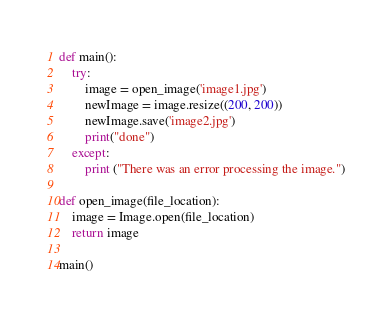<code> <loc_0><loc_0><loc_500><loc_500><_Python_>
def main():
    try:
        image = open_image('image1.jpg')
        newImage = image.resize((200, 200))
        newImage.save('image2.jpg')
        print("done")
    except:
        print ("There was an error processing the image.")

def open_image(file_location):
    image = Image.open(file_location)
    return image

main()</code> 